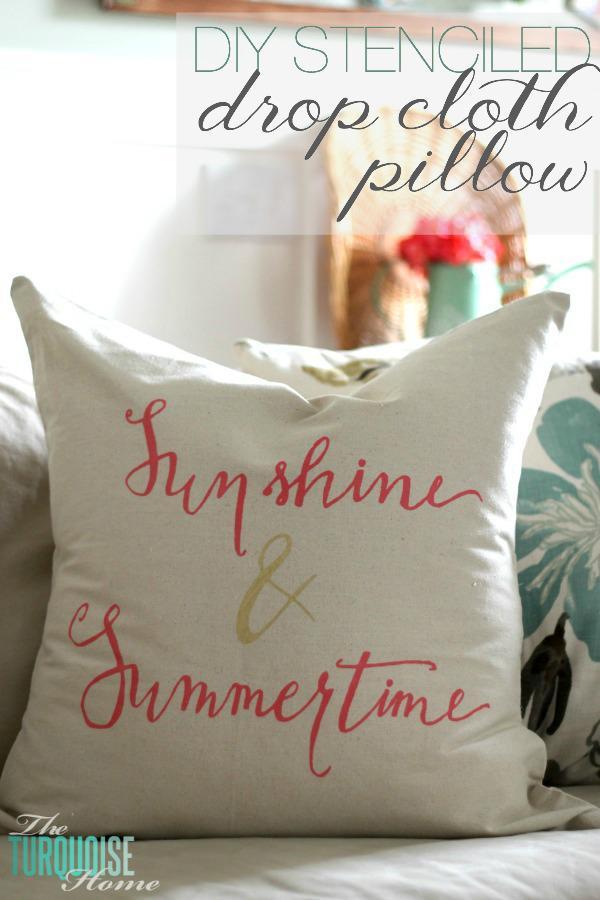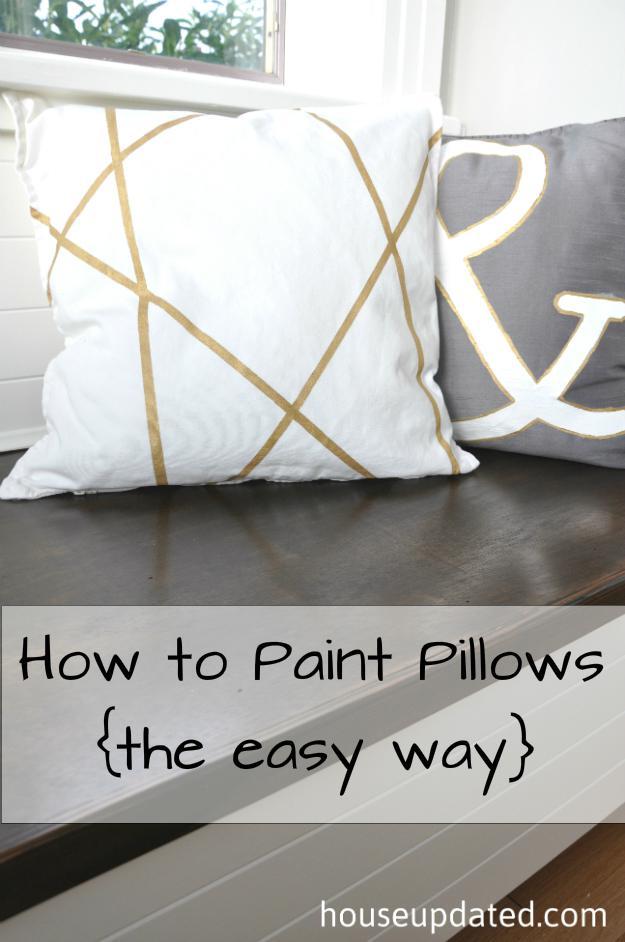The first image is the image on the left, the second image is the image on the right. Analyze the images presented: Is the assertion "There are two pillow on top of a brown surface." valid? Answer yes or no. Yes. 